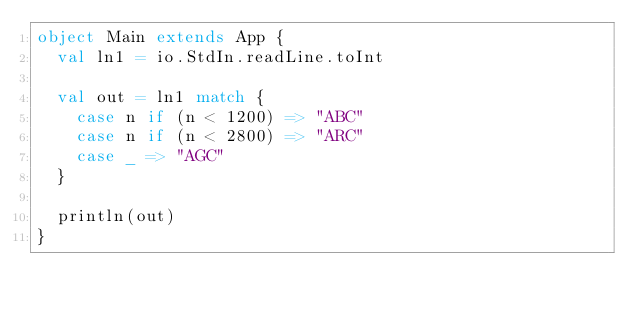Convert code to text. <code><loc_0><loc_0><loc_500><loc_500><_Scala_>object Main extends App {
  val ln1 = io.StdIn.readLine.toInt

  val out = ln1 match {
    case n if (n < 1200) => "ABC"
    case n if (n < 2800) => "ARC"
    case _ => "AGC"
  }

  println(out)
}</code> 